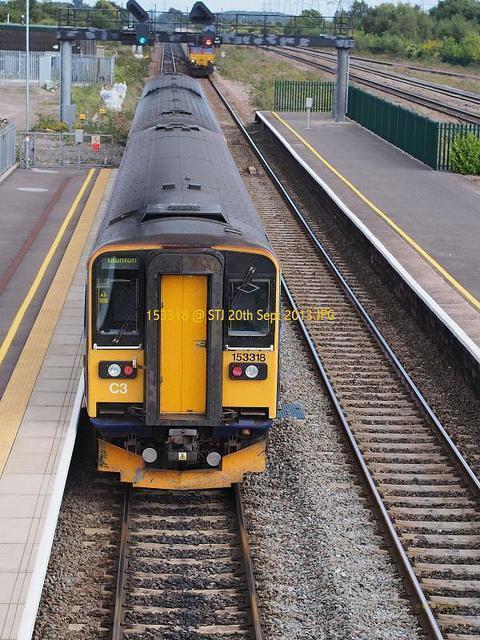How many people are wearing a birthday hat?
Give a very brief answer. 0. 